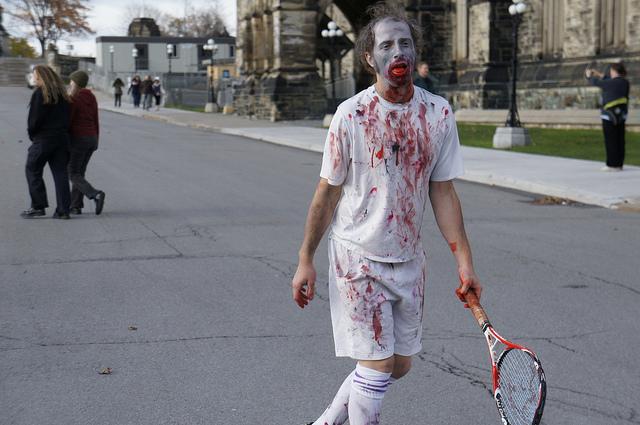What is the mans clothes covered with?
Write a very short answer. Blood. What just happened to this man?
Give a very brief answer. Zombie run. What does the man on the far right have on his back?
Give a very brief answer. Coat. What is in the man's left hand?
Concise answer only. Tennis racket. What is the zombie carrying?
Be succinct. Tennis racket. 